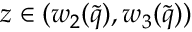Convert formula to latex. <formula><loc_0><loc_0><loc_500><loc_500>z \in ( w _ { 2 } ( \tilde { q } ) , w _ { 3 } ( \tilde { q } ) )</formula> 